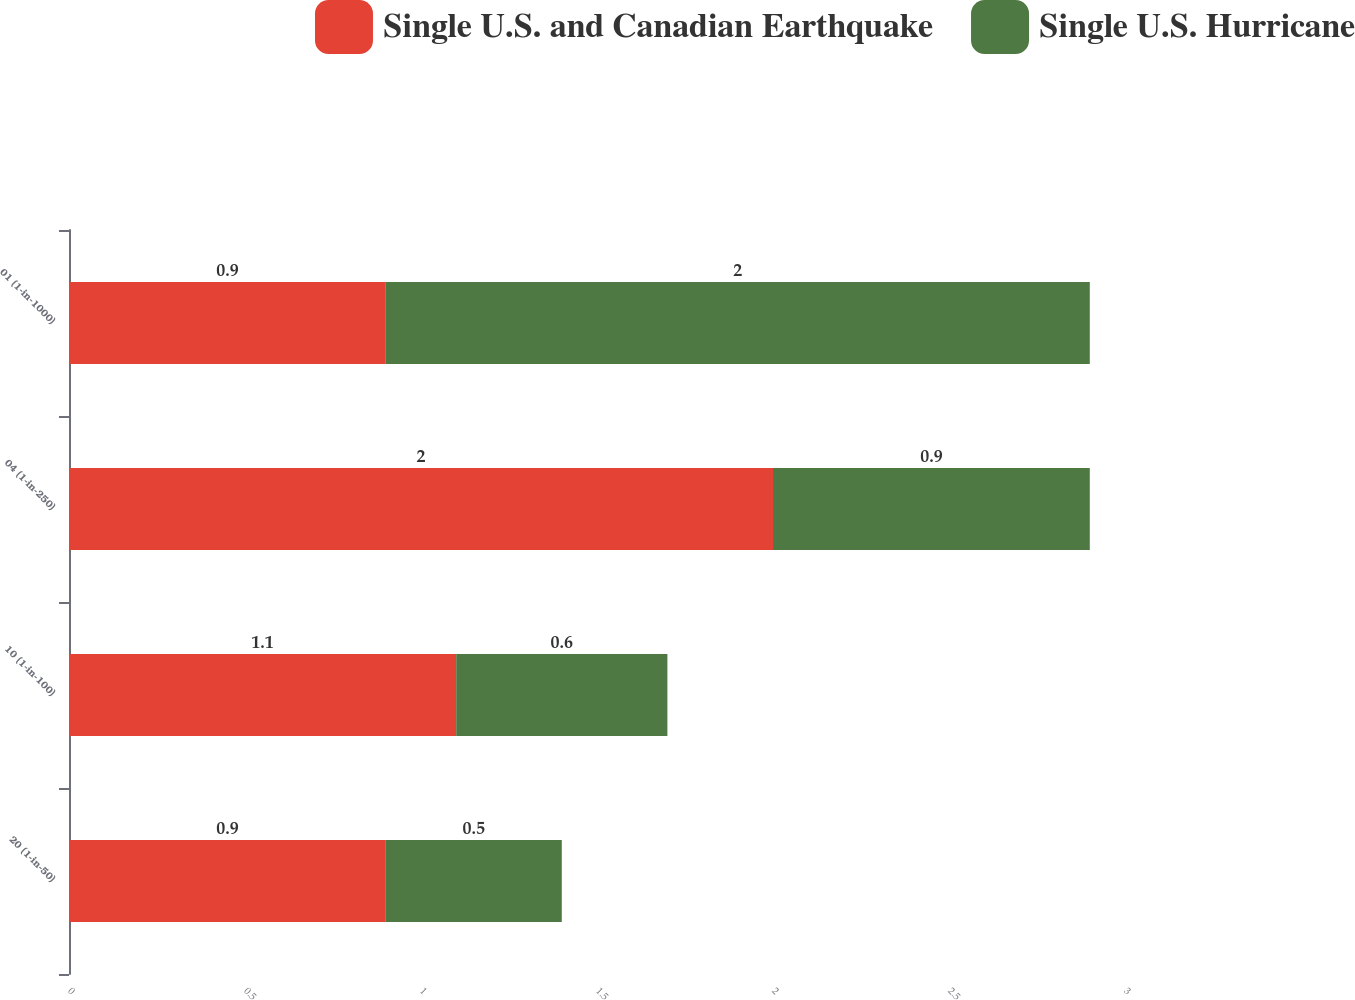Convert chart. <chart><loc_0><loc_0><loc_500><loc_500><stacked_bar_chart><ecel><fcel>20 (1-in-50)<fcel>10 (1-in-100)<fcel>04 (1-in-250)<fcel>01 (1-in-1000)<nl><fcel>Single U.S. and Canadian Earthquake<fcel>0.9<fcel>1.1<fcel>2<fcel>0.9<nl><fcel>Single U.S. Hurricane<fcel>0.5<fcel>0.6<fcel>0.9<fcel>2<nl></chart> 